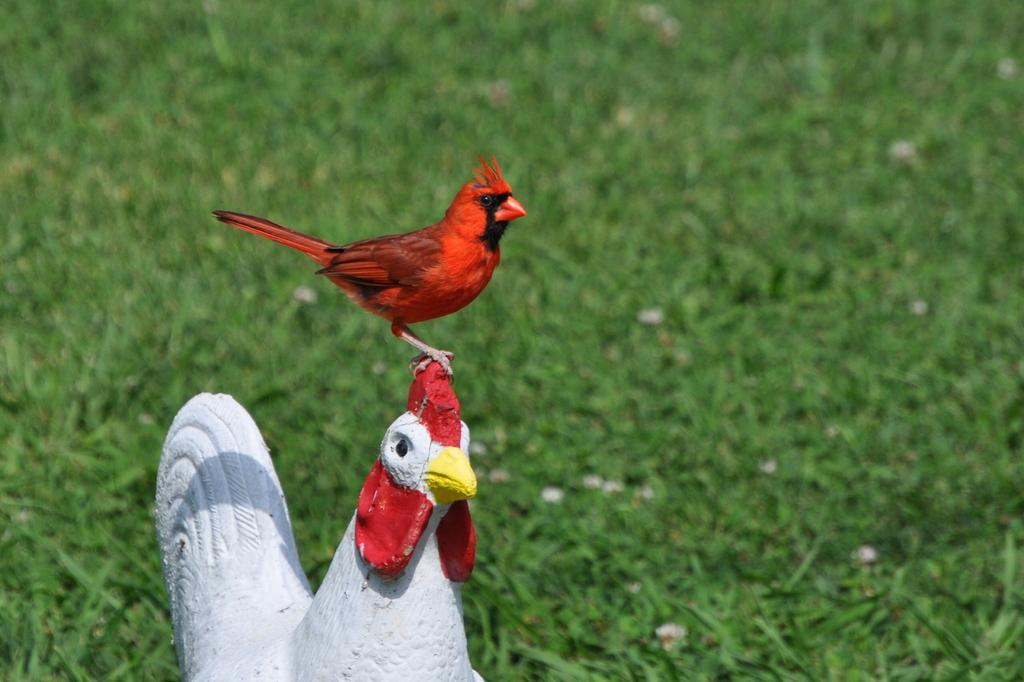What is the bird standing on in the image? The bird is standing on a statue in the image. What type of statue is the bird standing on? The statue is of a hen. Can you describe the background of the image? The background of the image is blurred. What type of vegetation is visible in the background of the image? There is grass visible in the background of the image. What type of grain is the writer using to feed the birds in the image? There is no writer or grain present in the image; it features a bird standing on a statue of a hen with a blurred background. 